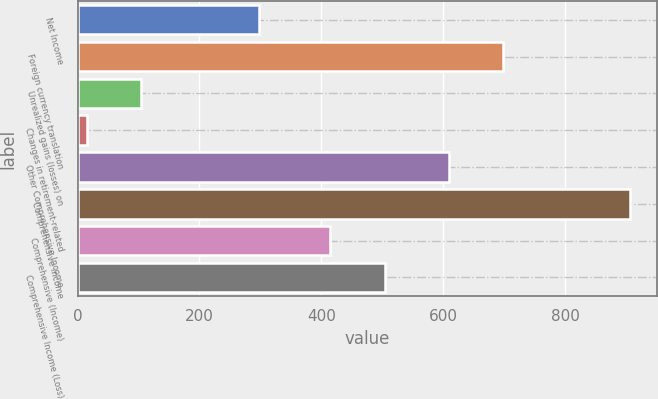Convert chart to OTSL. <chart><loc_0><loc_0><loc_500><loc_500><bar_chart><fcel>Net Income<fcel>Foreign currency translation<fcel>Unrealized gains (losses) on<fcel>Changes in retirement-related<fcel>Other Comprehensive Income<fcel>Comprehensive Income<fcel>Comprehensive (Income)<fcel>Comprehensive Income (Loss)<nl><fcel>297<fcel>698.1<fcel>104.1<fcel>15<fcel>609<fcel>906<fcel>415<fcel>504.1<nl></chart> 